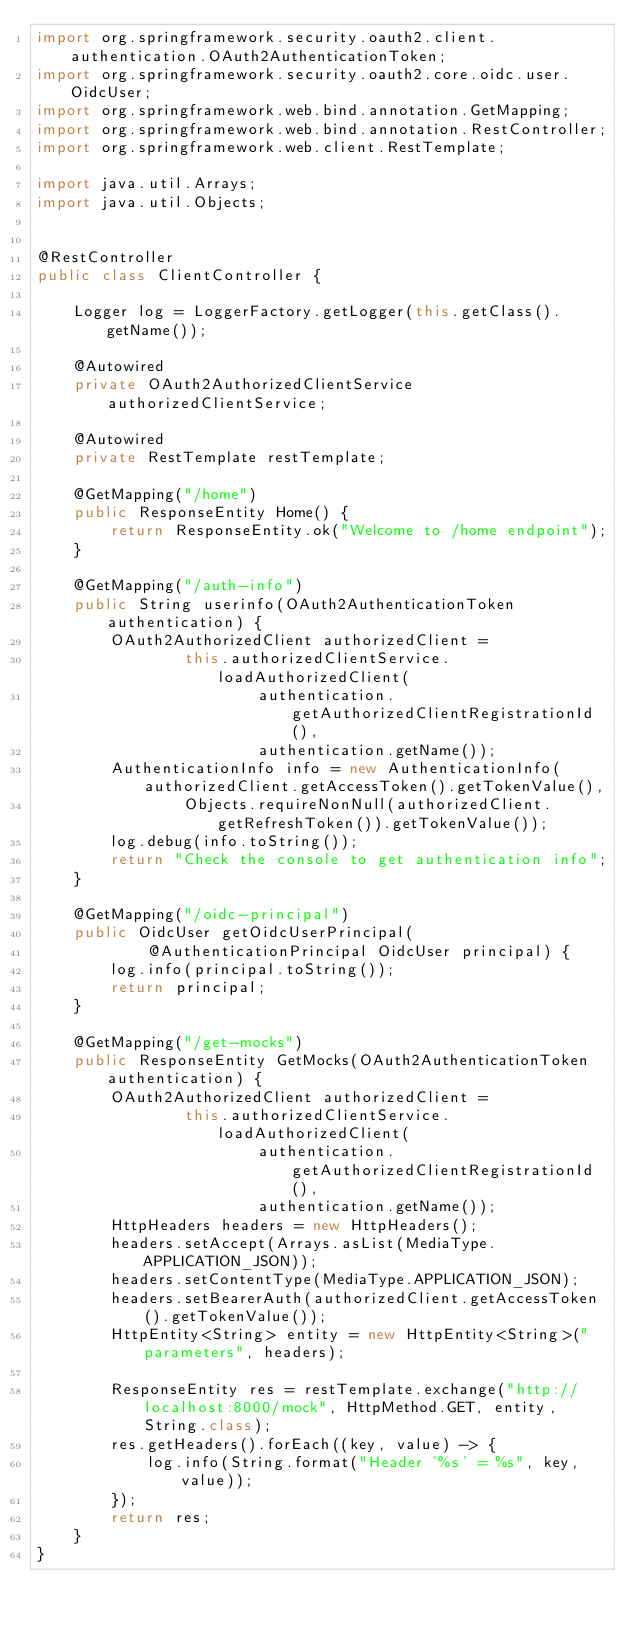Convert code to text. <code><loc_0><loc_0><loc_500><loc_500><_Java_>import org.springframework.security.oauth2.client.authentication.OAuth2AuthenticationToken;
import org.springframework.security.oauth2.core.oidc.user.OidcUser;
import org.springframework.web.bind.annotation.GetMapping;
import org.springframework.web.bind.annotation.RestController;
import org.springframework.web.client.RestTemplate;

import java.util.Arrays;
import java.util.Objects;


@RestController
public class ClientController {

    Logger log = LoggerFactory.getLogger(this.getClass().getName());

    @Autowired
    private OAuth2AuthorizedClientService authorizedClientService;

    @Autowired
    private RestTemplate restTemplate;

    @GetMapping("/home")
    public ResponseEntity Home() {
        return ResponseEntity.ok("Welcome to /home endpoint");
    }

    @GetMapping("/auth-info")
    public String userinfo(OAuth2AuthenticationToken authentication) {
        OAuth2AuthorizedClient authorizedClient =
                this.authorizedClientService.loadAuthorizedClient(
                        authentication.getAuthorizedClientRegistrationId(),
                        authentication.getName());
        AuthenticationInfo info = new AuthenticationInfo(authorizedClient.getAccessToken().getTokenValue(),
                Objects.requireNonNull(authorizedClient.getRefreshToken()).getTokenValue());
        log.debug(info.toString());
        return "Check the console to get authentication info";
    }

    @GetMapping("/oidc-principal")
    public OidcUser getOidcUserPrincipal(
            @AuthenticationPrincipal OidcUser principal) {
        log.info(principal.toString());
        return principal;
    }

    @GetMapping("/get-mocks")
    public ResponseEntity GetMocks(OAuth2AuthenticationToken authentication) {
        OAuth2AuthorizedClient authorizedClient =
                this.authorizedClientService.loadAuthorizedClient(
                        authentication.getAuthorizedClientRegistrationId(),
                        authentication.getName());
        HttpHeaders headers = new HttpHeaders();
        headers.setAccept(Arrays.asList(MediaType.APPLICATION_JSON));
        headers.setContentType(MediaType.APPLICATION_JSON);
        headers.setBearerAuth(authorizedClient.getAccessToken().getTokenValue());
        HttpEntity<String> entity = new HttpEntity<String>("parameters", headers);

        ResponseEntity res = restTemplate.exchange("http://localhost:8000/mock", HttpMethod.GET, entity, String.class);
        res.getHeaders().forEach((key, value) -> {
            log.info(String.format("Header '%s' = %s", key, value));
        });
        return res;
    }
}
</code> 